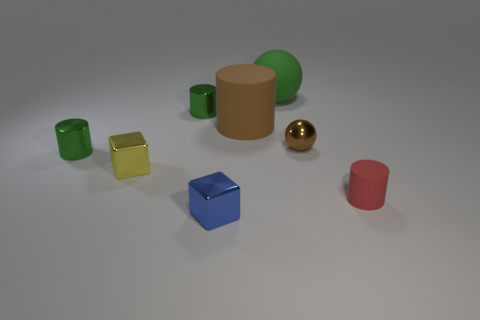Subtract all green cylinders. How many were subtracted if there are1green cylinders left? 1 Subtract all large rubber cylinders. How many cylinders are left? 3 Subtract all blocks. How many objects are left? 6 Subtract 2 spheres. How many spheres are left? 0 Subtract all red cubes. Subtract all yellow cylinders. How many cubes are left? 2 Subtract all cyan blocks. How many red spheres are left? 0 Subtract all tiny shiny objects. Subtract all brown metal balls. How many objects are left? 2 Add 3 matte cylinders. How many matte cylinders are left? 5 Add 4 cyan blocks. How many cyan blocks exist? 4 Add 2 tiny yellow blocks. How many objects exist? 10 